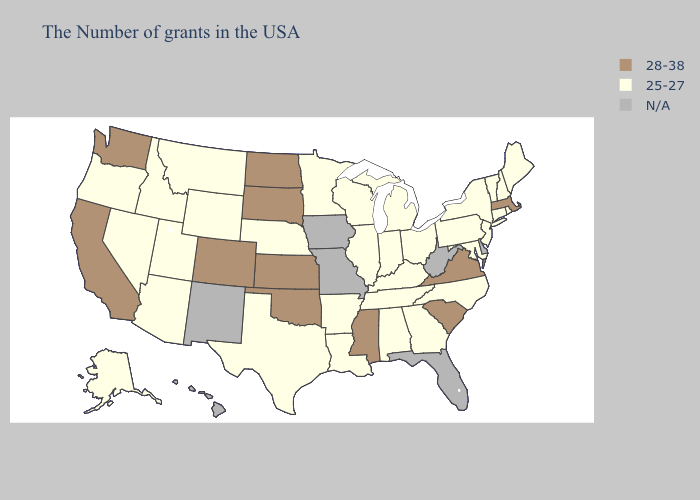Name the states that have a value in the range 25-27?
Short answer required. Maine, Rhode Island, New Hampshire, Vermont, Connecticut, New York, New Jersey, Maryland, Pennsylvania, North Carolina, Ohio, Georgia, Michigan, Kentucky, Indiana, Alabama, Tennessee, Wisconsin, Illinois, Louisiana, Arkansas, Minnesota, Nebraska, Texas, Wyoming, Utah, Montana, Arizona, Idaho, Nevada, Oregon, Alaska. Does Washington have the lowest value in the USA?
Write a very short answer. No. What is the highest value in states that border Texas?
Short answer required. 28-38. What is the value of Alaska?
Quick response, please. 25-27. Among the states that border New Hampshire , does Massachusetts have the highest value?
Quick response, please. Yes. What is the lowest value in the South?
Give a very brief answer. 25-27. Among the states that border New Hampshire , does Maine have the highest value?
Write a very short answer. No. Does Louisiana have the highest value in the South?
Give a very brief answer. No. Among the states that border Tennessee , which have the lowest value?
Answer briefly. North Carolina, Georgia, Kentucky, Alabama, Arkansas. What is the value of Ohio?
Give a very brief answer. 25-27. What is the value of Virginia?
Write a very short answer. 28-38. Which states hav the highest value in the West?
Keep it brief. Colorado, California, Washington. What is the value of West Virginia?
Be succinct. N/A. Name the states that have a value in the range N/A?
Short answer required. Delaware, West Virginia, Florida, Missouri, Iowa, New Mexico, Hawaii. 